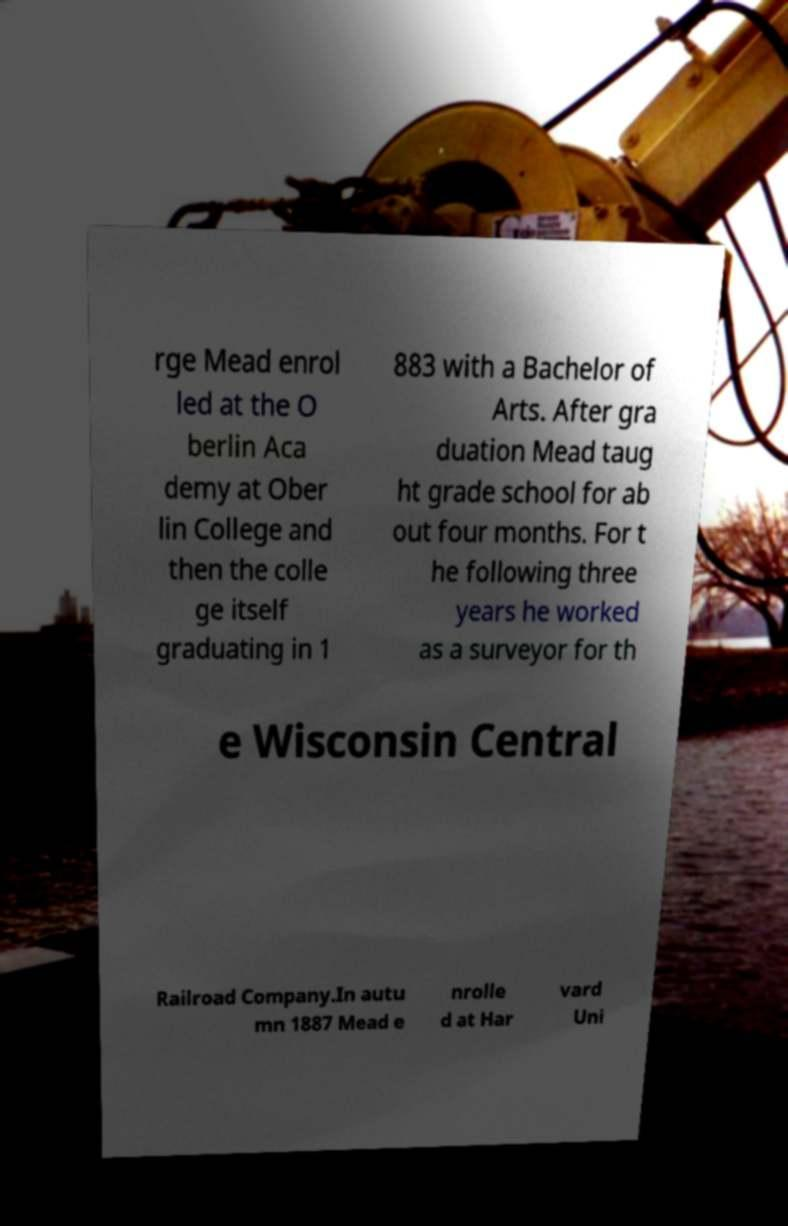There's text embedded in this image that I need extracted. Can you transcribe it verbatim? rge Mead enrol led at the O berlin Aca demy at Ober lin College and then the colle ge itself graduating in 1 883 with a Bachelor of Arts. After gra duation Mead taug ht grade school for ab out four months. For t he following three years he worked as a surveyor for th e Wisconsin Central Railroad Company.In autu mn 1887 Mead e nrolle d at Har vard Uni 